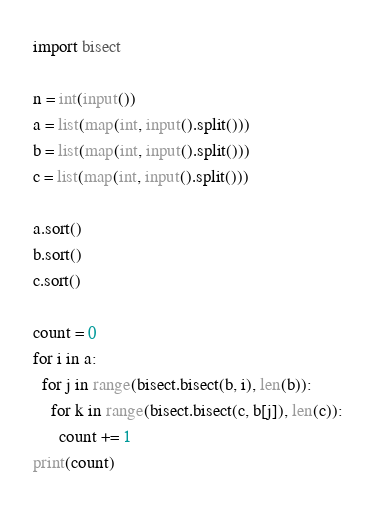<code> <loc_0><loc_0><loc_500><loc_500><_Python_>import bisect

n = int(input())
a = list(map(int, input().split()))
b = list(map(int, input().split()))
c = list(map(int, input().split()))

a.sort()
b.sort()
c.sort()

count = 0
for i in a:
  for j in range(bisect.bisect(b, i), len(b)):
    for k in range(bisect.bisect(c, b[j]), len(c)):
      count += 1
print(count)
</code> 